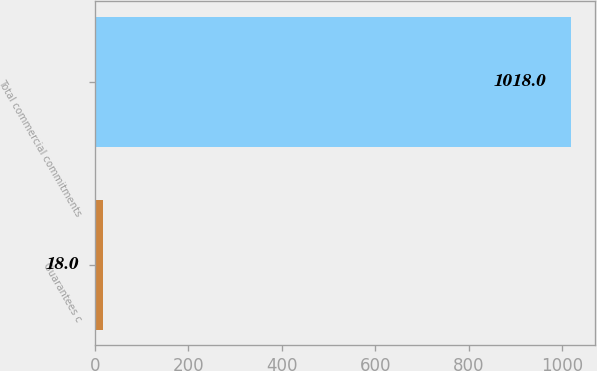Convert chart. <chart><loc_0><loc_0><loc_500><loc_500><bar_chart><fcel>Guarantees c<fcel>Total commercial commitments<nl><fcel>18<fcel>1018<nl></chart> 